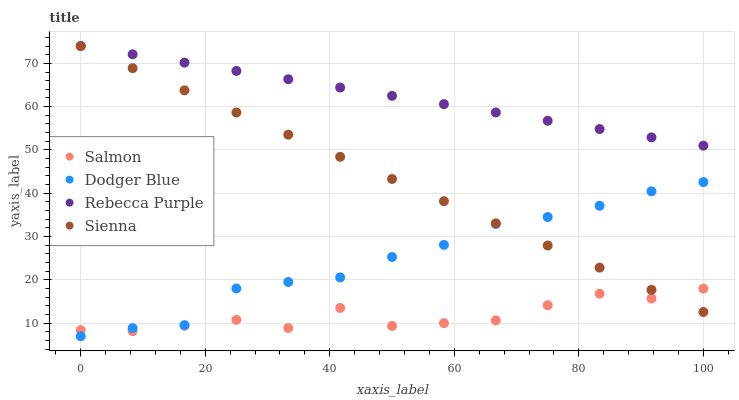Does Salmon have the minimum area under the curve?
Answer yes or no. Yes. Does Rebecca Purple have the maximum area under the curve?
Answer yes or no. Yes. Does Dodger Blue have the minimum area under the curve?
Answer yes or no. No. Does Dodger Blue have the maximum area under the curve?
Answer yes or no. No. Is Rebecca Purple the smoothest?
Answer yes or no. Yes. Is Salmon the roughest?
Answer yes or no. Yes. Is Dodger Blue the smoothest?
Answer yes or no. No. Is Dodger Blue the roughest?
Answer yes or no. No. Does Dodger Blue have the lowest value?
Answer yes or no. Yes. Does Salmon have the lowest value?
Answer yes or no. No. Does Rebecca Purple have the highest value?
Answer yes or no. Yes. Does Dodger Blue have the highest value?
Answer yes or no. No. Is Dodger Blue less than Rebecca Purple?
Answer yes or no. Yes. Is Rebecca Purple greater than Salmon?
Answer yes or no. Yes. Does Dodger Blue intersect Salmon?
Answer yes or no. Yes. Is Dodger Blue less than Salmon?
Answer yes or no. No. Is Dodger Blue greater than Salmon?
Answer yes or no. No. Does Dodger Blue intersect Rebecca Purple?
Answer yes or no. No. 